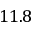Convert formula to latex. <formula><loc_0><loc_0><loc_500><loc_500>1 1 . 8</formula> 